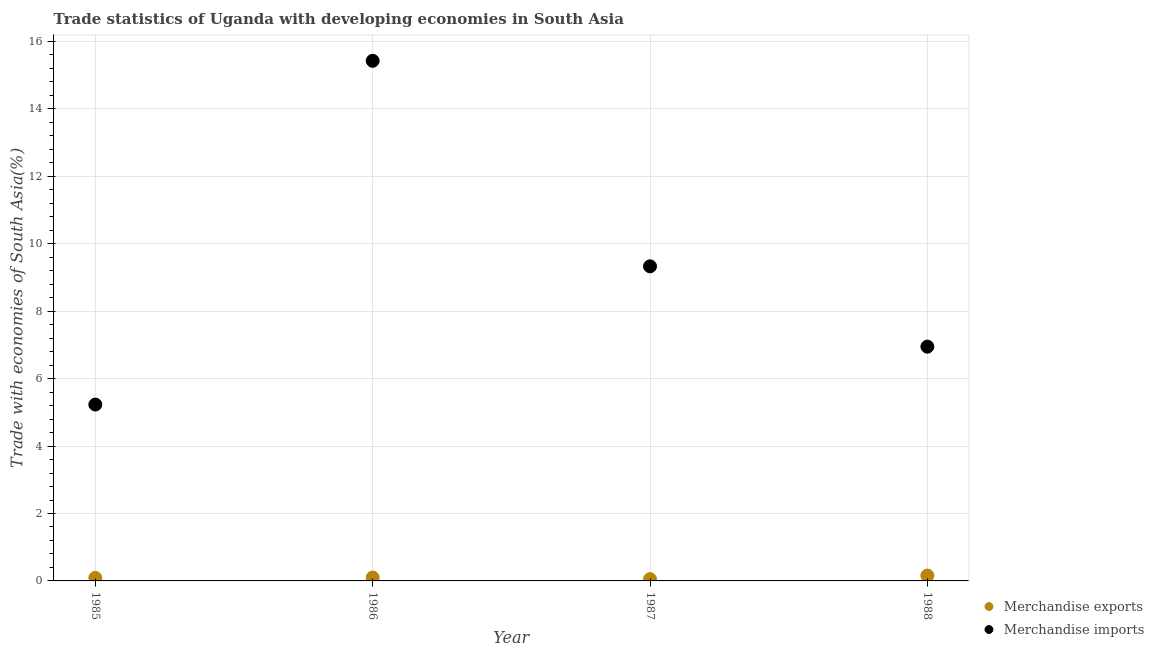What is the merchandise imports in 1985?
Give a very brief answer. 5.23. Across all years, what is the maximum merchandise imports?
Your answer should be compact. 15.43. Across all years, what is the minimum merchandise exports?
Your response must be concise. 0.05. In which year was the merchandise imports maximum?
Offer a very short reply. 1986. What is the total merchandise imports in the graph?
Offer a very short reply. 36.94. What is the difference between the merchandise imports in 1985 and that in 1986?
Keep it short and to the point. -10.2. What is the difference between the merchandise imports in 1985 and the merchandise exports in 1987?
Your answer should be compact. 5.18. What is the average merchandise imports per year?
Offer a very short reply. 9.23. In the year 1985, what is the difference between the merchandise imports and merchandise exports?
Ensure brevity in your answer.  5.14. In how many years, is the merchandise imports greater than 10.4 %?
Keep it short and to the point. 1. What is the ratio of the merchandise imports in 1986 to that in 1988?
Your response must be concise. 2.22. Is the difference between the merchandise exports in 1986 and 1987 greater than the difference between the merchandise imports in 1986 and 1987?
Your response must be concise. No. What is the difference between the highest and the second highest merchandise exports?
Provide a succinct answer. 0.06. What is the difference between the highest and the lowest merchandise imports?
Provide a short and direct response. 10.2. Is the sum of the merchandise exports in 1987 and 1988 greater than the maximum merchandise imports across all years?
Provide a succinct answer. No. Does the merchandise exports monotonically increase over the years?
Your response must be concise. No. Is the merchandise imports strictly greater than the merchandise exports over the years?
Your answer should be very brief. Yes. Is the merchandise imports strictly less than the merchandise exports over the years?
Offer a very short reply. No. How many dotlines are there?
Provide a succinct answer. 2. What is the difference between two consecutive major ticks on the Y-axis?
Keep it short and to the point. 2. How many legend labels are there?
Make the answer very short. 2. How are the legend labels stacked?
Your answer should be compact. Vertical. What is the title of the graph?
Your answer should be compact. Trade statistics of Uganda with developing economies in South Asia. What is the label or title of the X-axis?
Offer a terse response. Year. What is the label or title of the Y-axis?
Your answer should be compact. Trade with economies of South Asia(%). What is the Trade with economies of South Asia(%) of Merchandise exports in 1985?
Offer a terse response. 0.09. What is the Trade with economies of South Asia(%) of Merchandise imports in 1985?
Your response must be concise. 5.23. What is the Trade with economies of South Asia(%) in Merchandise exports in 1986?
Ensure brevity in your answer.  0.1. What is the Trade with economies of South Asia(%) of Merchandise imports in 1986?
Provide a short and direct response. 15.43. What is the Trade with economies of South Asia(%) of Merchandise exports in 1987?
Offer a terse response. 0.05. What is the Trade with economies of South Asia(%) of Merchandise imports in 1987?
Offer a terse response. 9.33. What is the Trade with economies of South Asia(%) of Merchandise exports in 1988?
Offer a terse response. 0.16. What is the Trade with economies of South Asia(%) of Merchandise imports in 1988?
Offer a very short reply. 6.95. Across all years, what is the maximum Trade with economies of South Asia(%) of Merchandise exports?
Ensure brevity in your answer.  0.16. Across all years, what is the maximum Trade with economies of South Asia(%) in Merchandise imports?
Make the answer very short. 15.43. Across all years, what is the minimum Trade with economies of South Asia(%) of Merchandise exports?
Provide a short and direct response. 0.05. Across all years, what is the minimum Trade with economies of South Asia(%) of Merchandise imports?
Ensure brevity in your answer.  5.23. What is the total Trade with economies of South Asia(%) of Merchandise exports in the graph?
Provide a short and direct response. 0.4. What is the total Trade with economies of South Asia(%) in Merchandise imports in the graph?
Provide a short and direct response. 36.94. What is the difference between the Trade with economies of South Asia(%) of Merchandise exports in 1985 and that in 1986?
Your answer should be very brief. -0.01. What is the difference between the Trade with economies of South Asia(%) of Merchandise imports in 1985 and that in 1986?
Keep it short and to the point. -10.2. What is the difference between the Trade with economies of South Asia(%) in Merchandise exports in 1985 and that in 1987?
Keep it short and to the point. 0.04. What is the difference between the Trade with economies of South Asia(%) of Merchandise imports in 1985 and that in 1987?
Make the answer very short. -4.1. What is the difference between the Trade with economies of South Asia(%) in Merchandise exports in 1985 and that in 1988?
Your response must be concise. -0.07. What is the difference between the Trade with economies of South Asia(%) in Merchandise imports in 1985 and that in 1988?
Provide a succinct answer. -1.72. What is the difference between the Trade with economies of South Asia(%) in Merchandise exports in 1986 and that in 1987?
Ensure brevity in your answer.  0.05. What is the difference between the Trade with economies of South Asia(%) in Merchandise imports in 1986 and that in 1987?
Make the answer very short. 6.1. What is the difference between the Trade with economies of South Asia(%) of Merchandise exports in 1986 and that in 1988?
Keep it short and to the point. -0.06. What is the difference between the Trade with economies of South Asia(%) of Merchandise imports in 1986 and that in 1988?
Provide a short and direct response. 8.48. What is the difference between the Trade with economies of South Asia(%) in Merchandise exports in 1987 and that in 1988?
Provide a succinct answer. -0.11. What is the difference between the Trade with economies of South Asia(%) in Merchandise imports in 1987 and that in 1988?
Give a very brief answer. 2.38. What is the difference between the Trade with economies of South Asia(%) of Merchandise exports in 1985 and the Trade with economies of South Asia(%) of Merchandise imports in 1986?
Provide a short and direct response. -15.34. What is the difference between the Trade with economies of South Asia(%) of Merchandise exports in 1985 and the Trade with economies of South Asia(%) of Merchandise imports in 1987?
Ensure brevity in your answer.  -9.24. What is the difference between the Trade with economies of South Asia(%) of Merchandise exports in 1985 and the Trade with economies of South Asia(%) of Merchandise imports in 1988?
Your response must be concise. -6.86. What is the difference between the Trade with economies of South Asia(%) of Merchandise exports in 1986 and the Trade with economies of South Asia(%) of Merchandise imports in 1987?
Keep it short and to the point. -9.23. What is the difference between the Trade with economies of South Asia(%) of Merchandise exports in 1986 and the Trade with economies of South Asia(%) of Merchandise imports in 1988?
Your answer should be compact. -6.85. What is the difference between the Trade with economies of South Asia(%) in Merchandise exports in 1987 and the Trade with economies of South Asia(%) in Merchandise imports in 1988?
Your answer should be very brief. -6.9. What is the average Trade with economies of South Asia(%) in Merchandise exports per year?
Make the answer very short. 0.1. What is the average Trade with economies of South Asia(%) of Merchandise imports per year?
Provide a succinct answer. 9.23. In the year 1985, what is the difference between the Trade with economies of South Asia(%) of Merchandise exports and Trade with economies of South Asia(%) of Merchandise imports?
Your response must be concise. -5.14. In the year 1986, what is the difference between the Trade with economies of South Asia(%) of Merchandise exports and Trade with economies of South Asia(%) of Merchandise imports?
Provide a succinct answer. -15.33. In the year 1987, what is the difference between the Trade with economies of South Asia(%) in Merchandise exports and Trade with economies of South Asia(%) in Merchandise imports?
Provide a short and direct response. -9.28. In the year 1988, what is the difference between the Trade with economies of South Asia(%) of Merchandise exports and Trade with economies of South Asia(%) of Merchandise imports?
Your answer should be very brief. -6.79. What is the ratio of the Trade with economies of South Asia(%) in Merchandise exports in 1985 to that in 1986?
Give a very brief answer. 0.91. What is the ratio of the Trade with economies of South Asia(%) of Merchandise imports in 1985 to that in 1986?
Give a very brief answer. 0.34. What is the ratio of the Trade with economies of South Asia(%) in Merchandise exports in 1985 to that in 1987?
Your answer should be very brief. 1.76. What is the ratio of the Trade with economies of South Asia(%) of Merchandise imports in 1985 to that in 1987?
Offer a terse response. 0.56. What is the ratio of the Trade with economies of South Asia(%) in Merchandise exports in 1985 to that in 1988?
Make the answer very short. 0.57. What is the ratio of the Trade with economies of South Asia(%) of Merchandise imports in 1985 to that in 1988?
Your response must be concise. 0.75. What is the ratio of the Trade with economies of South Asia(%) in Merchandise exports in 1986 to that in 1987?
Make the answer very short. 1.94. What is the ratio of the Trade with economies of South Asia(%) of Merchandise imports in 1986 to that in 1987?
Ensure brevity in your answer.  1.65. What is the ratio of the Trade with economies of South Asia(%) of Merchandise exports in 1986 to that in 1988?
Offer a terse response. 0.63. What is the ratio of the Trade with economies of South Asia(%) in Merchandise imports in 1986 to that in 1988?
Provide a short and direct response. 2.22. What is the ratio of the Trade with economies of South Asia(%) of Merchandise exports in 1987 to that in 1988?
Provide a succinct answer. 0.32. What is the ratio of the Trade with economies of South Asia(%) of Merchandise imports in 1987 to that in 1988?
Offer a terse response. 1.34. What is the difference between the highest and the second highest Trade with economies of South Asia(%) in Merchandise exports?
Give a very brief answer. 0.06. What is the difference between the highest and the second highest Trade with economies of South Asia(%) in Merchandise imports?
Your answer should be very brief. 6.1. What is the difference between the highest and the lowest Trade with economies of South Asia(%) of Merchandise exports?
Your answer should be very brief. 0.11. What is the difference between the highest and the lowest Trade with economies of South Asia(%) of Merchandise imports?
Provide a succinct answer. 10.2. 